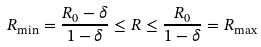Convert formula to latex. <formula><loc_0><loc_0><loc_500><loc_500>R _ { \min } = \frac { R _ { 0 } - \delta } { 1 - \delta } \leq R \leq \frac { R _ { 0 } } { 1 - \delta } = R _ { \max }</formula> 